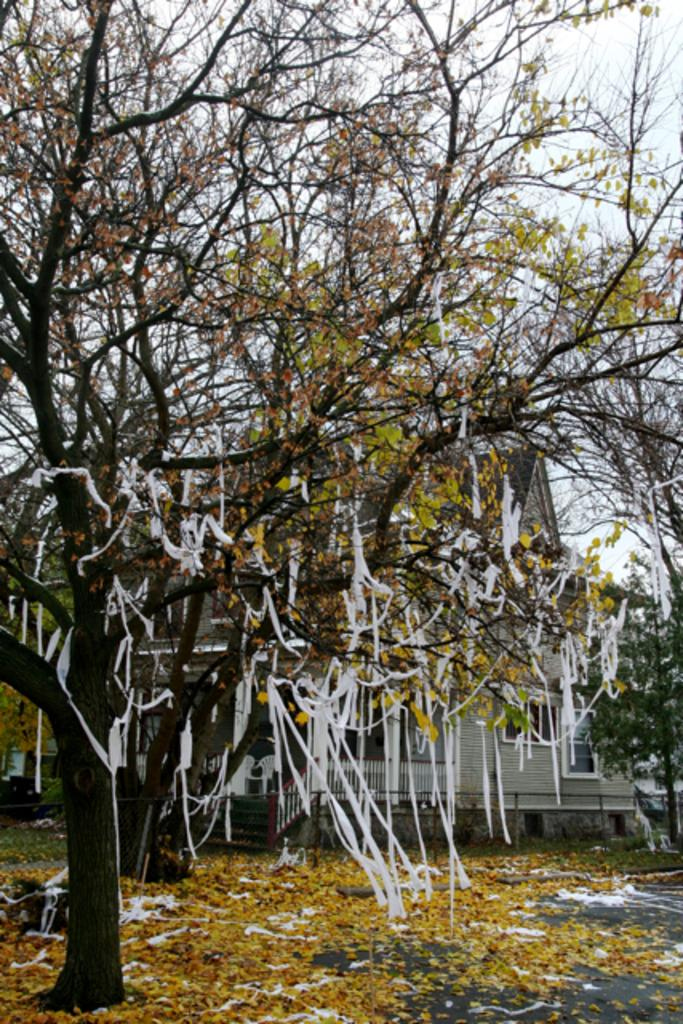What type of plant can be seen in the image? There is a tree in the image. What is the color of the tree? The tree is green. What other structure is visible in the image? There is a building in the image. What is the color of the building? The building is gray. What is hanging from the tree in the image? There are white color ribbons hanging from the tree. What part of the natural environment is visible in the image? The sky is visible in the image and appears white. How far away is the pest from the tree in the image? There is no pest present in the image, so it is not possible to determine the distance between a pest and the tree. 